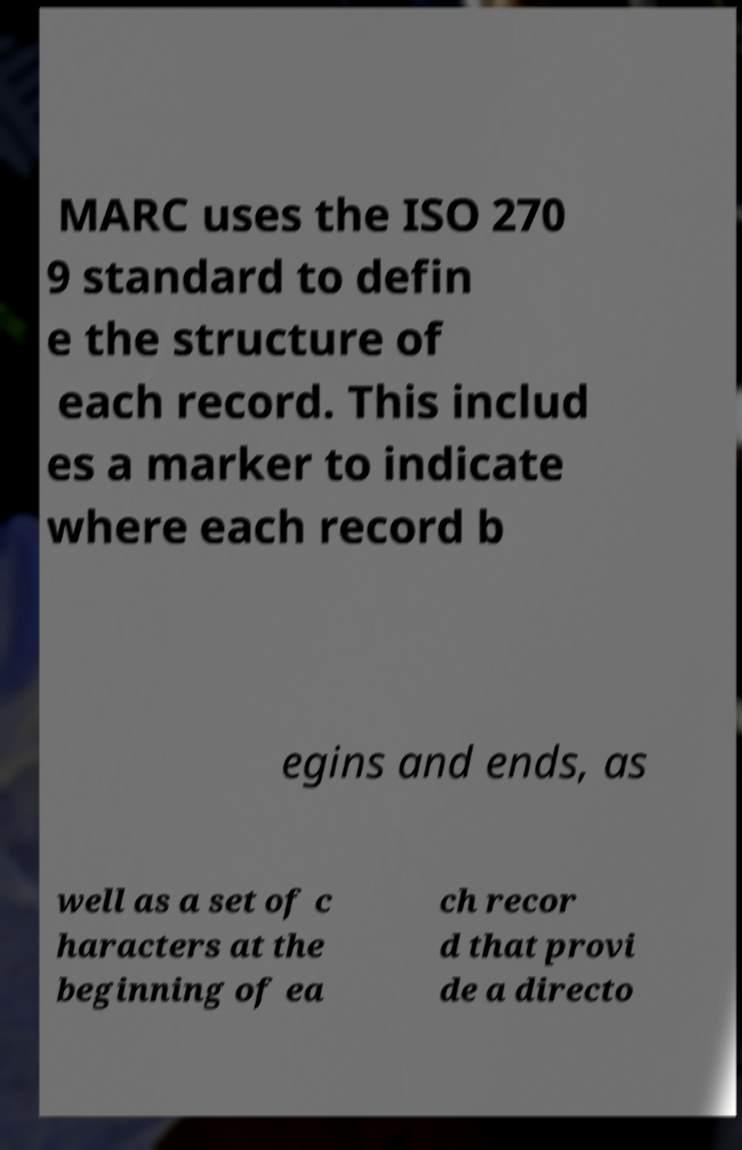What messages or text are displayed in this image? I need them in a readable, typed format. MARC uses the ISO 270 9 standard to defin e the structure of each record. This includ es a marker to indicate where each record b egins and ends, as well as a set of c haracters at the beginning of ea ch recor d that provi de a directo 